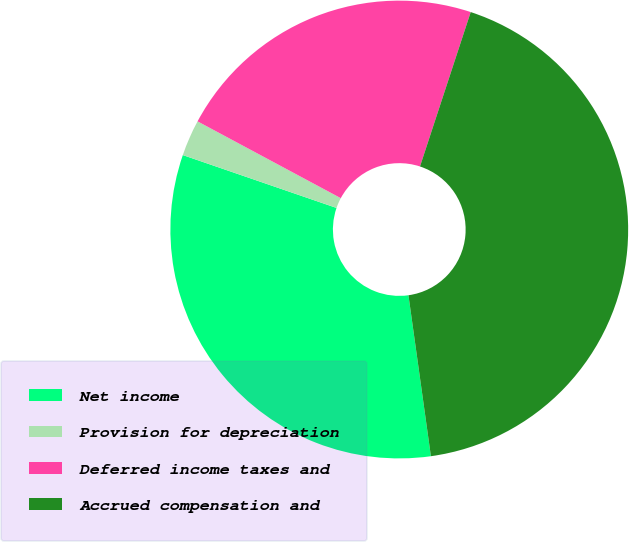Convert chart to OTSL. <chart><loc_0><loc_0><loc_500><loc_500><pie_chart><fcel>Net income<fcel>Provision for depreciation<fcel>Deferred income taxes and<fcel>Accrued compensation and<nl><fcel>32.48%<fcel>2.56%<fcel>22.22%<fcel>42.74%<nl></chart> 